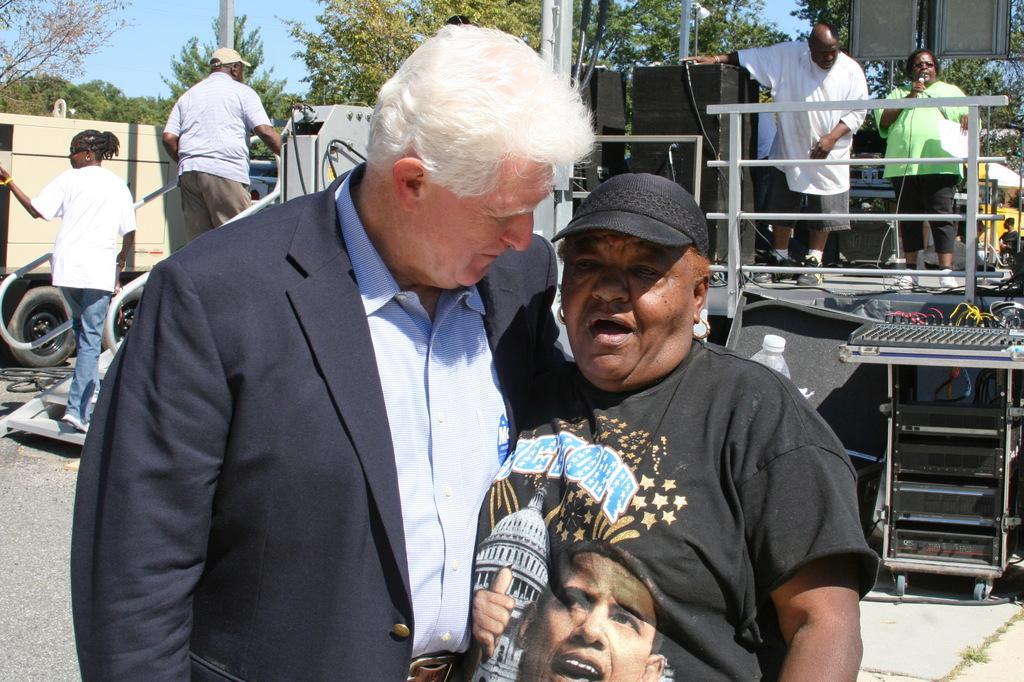Could you give a brief overview of what you see in this image? In this image I can see two persons standing. In the background there are five other persons and there are vehicles. Also there is an iron platform, there are speakers and there are some other objects. There are trees and there is sky. 